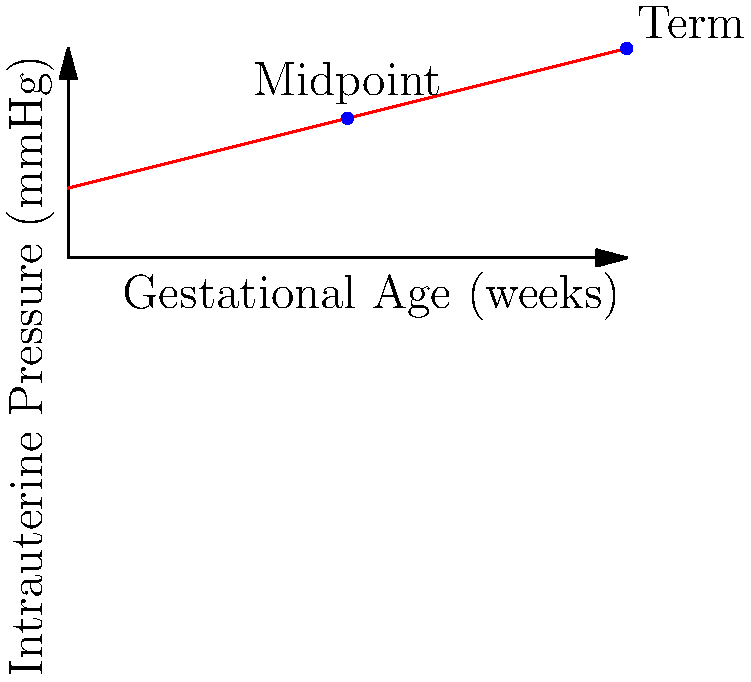In an artificial womb environment, the intrauterine pressure increases linearly with gestational age. If the initial pressure is 5 mmHg and reaches 15 mmHg at full term (40 weeks), calculate the pressure experienced by the fetus at 20 weeks gestation. How might this pressure affect fetal development compared to a natural womb? To solve this problem, we'll follow these steps:

1. Determine the rate of pressure increase:
   * Pressure change = 15 mmHg - 5 mmHg = 10 mmHg
   * Time period = 40 weeks - 0 weeks = 40 weeks
   * Rate of increase = $\frac{10 \text{ mmHg}}{40 \text{ weeks}} = 0.25 \text{ mmHg/week}$

2. Calculate the pressure at 20 weeks:
   * Initial pressure = 5 mmHg
   * Pressure increase over 20 weeks = $0.25 \text{ mmHg/week} \times 20 \text{ weeks} = 5 \text{ mmHg}$
   * Pressure at 20 weeks = 5 mmHg + 5 mmHg = 10 mmHg

3. Comparison to natural womb:
   * The linear increase in pressure in the artificial womb may not perfectly mimic the natural womb, where pressure changes can be more dynamic.
   * In a natural womb, pressures typically range from 5-15 mmHg, with fluctuations due to maternal activity, contractions, and fetal movement.
   * The consistent pressure in the artificial womb might affect:
     a. Fetal movement patterns
     b. Development of the musculoskeletal system
     c. Cardiovascular adaptations
   * These differences could have implications for fetal development and may require careful monitoring and adjustment in artificial womb design.
Answer: 10 mmHg; may affect fetal movement, musculoskeletal and cardiovascular development due to consistent pressure. 